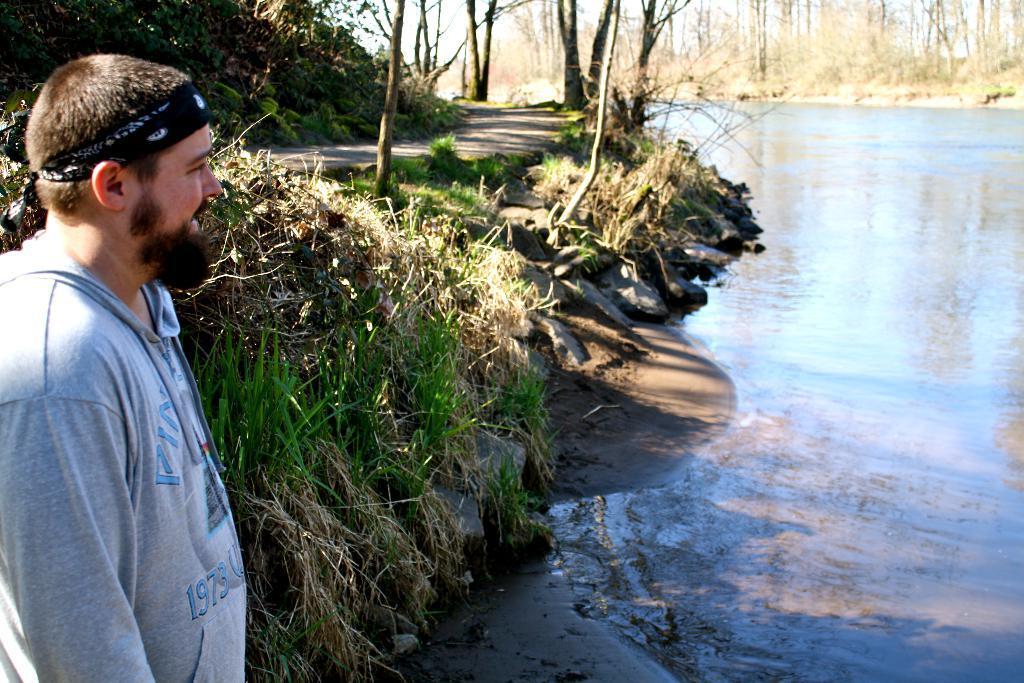Please provide a concise description of this image. In this image there is a person, there is grass, there are trees on the left corner. There is water on the right corner. There is water and there are trees in the background. And there is sky at the top. 